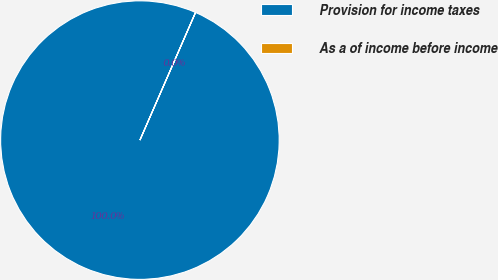<chart> <loc_0><loc_0><loc_500><loc_500><pie_chart><fcel>Provision for income taxes<fcel>As a of income before income<nl><fcel>99.99%<fcel>0.01%<nl></chart> 